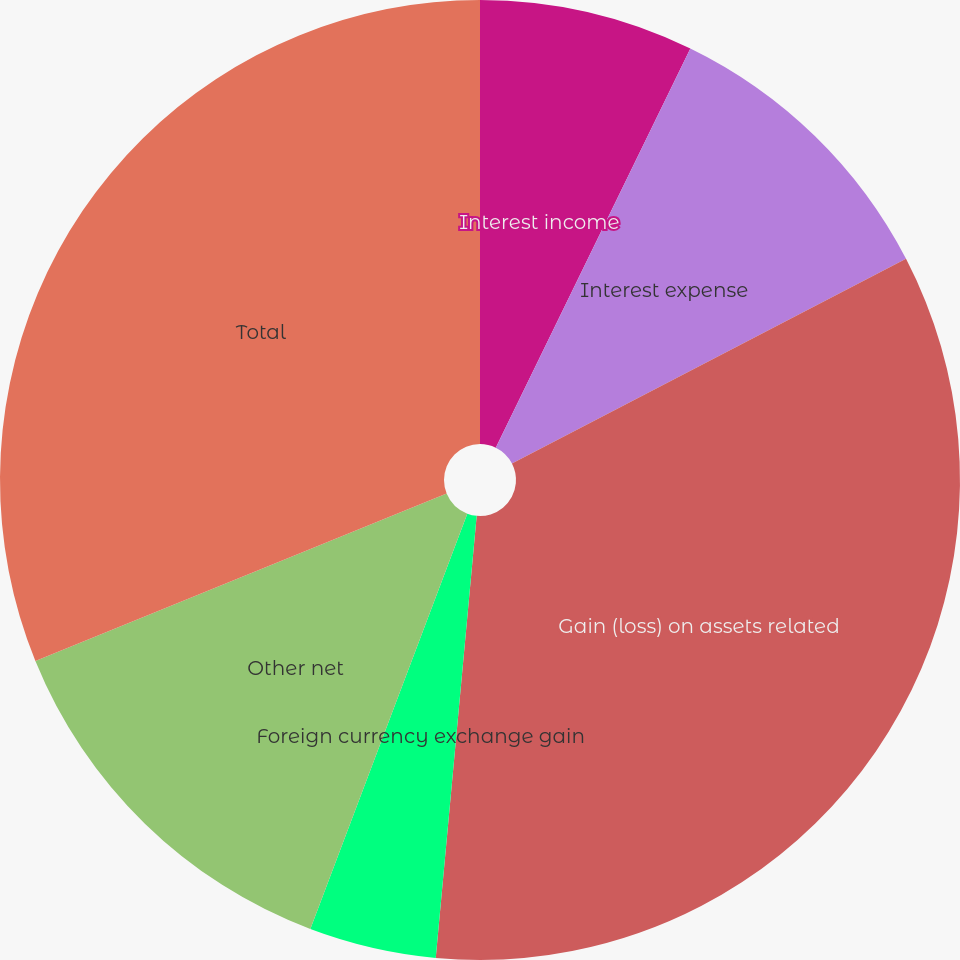Convert chart. <chart><loc_0><loc_0><loc_500><loc_500><pie_chart><fcel>Interest income<fcel>Interest expense<fcel>Gain (loss) on assets related<fcel>Foreign currency exchange gain<fcel>Other net<fcel>Total<nl><fcel>7.22%<fcel>10.16%<fcel>34.09%<fcel>4.28%<fcel>13.1%<fcel>31.15%<nl></chart> 